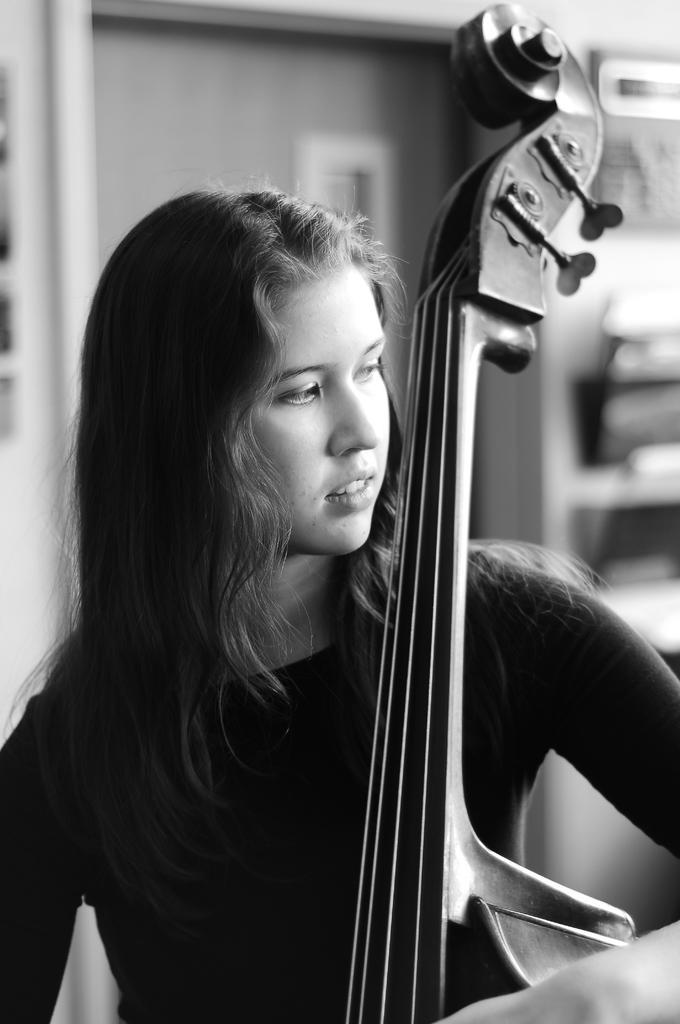Could you give a brief overview of what you see in this image? In this picture there is a girl who is standing at the center of the image, by holding the guitar in her hand, she is facing to the right side of the image and there is a door behind the girl. 